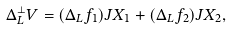Convert formula to latex. <formula><loc_0><loc_0><loc_500><loc_500>\Delta _ { L } ^ { \perp } V = ( \Delta _ { L } f _ { 1 } ) J X _ { 1 } + ( \Delta _ { L } f _ { 2 } ) J X _ { 2 } ,</formula> 